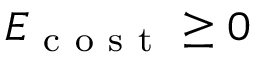Convert formula to latex. <formula><loc_0><loc_0><loc_500><loc_500>E _ { c o s t } \geq 0</formula> 